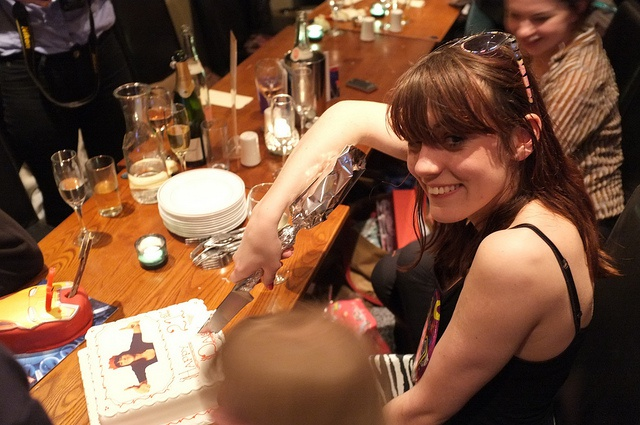Describe the objects in this image and their specific colors. I can see dining table in black, ivory, brown, red, and maroon tones, people in black, maroon, and brown tones, people in black, maroon, and gray tones, people in black, salmon, maroon, and brown tones, and people in black, maroon, and brown tones in this image. 